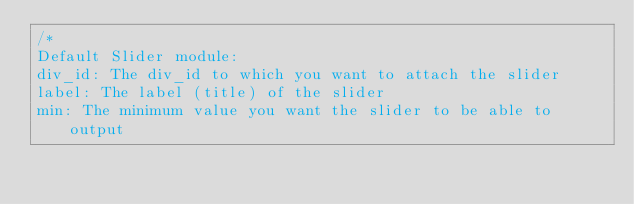Convert code to text. <code><loc_0><loc_0><loc_500><loc_500><_JavaScript_>/*
Default Slider module:
div_id: The div_id to which you want to attach the slider
label: The label (title) of the slider
min: The minimum value you want the slider to be able to output</code> 